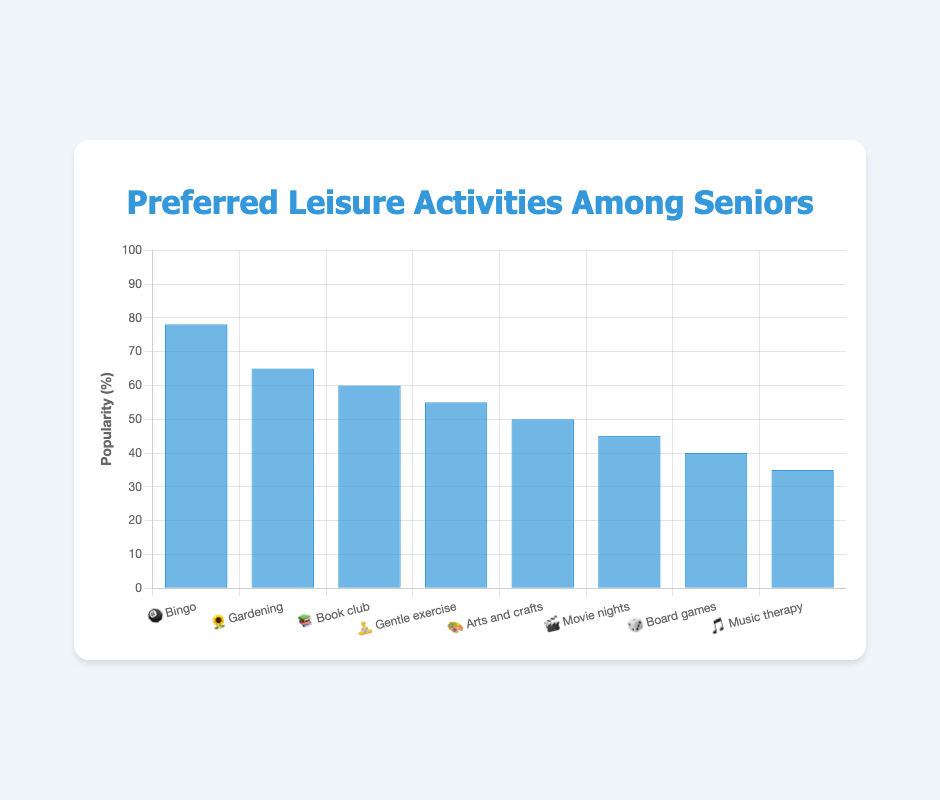What is the most popular leisure activity among seniors? Look at the top bar of the chart to identify the activity with the highest popularity percentage. The bar for "Bingo" 🎱 reaches 78%, which is the highest.
Answer: Bingo 🎱 Which activity has a popularity of 55%? Check each bar label and its corresponding height until finding the one that corresponds to 55%. "Gentle exercise" 🧘 has a 55% popularity.
Answer: Gentle exercise 🧘 How much more popular is Bingo 🎱 compared to Arts and crafts 🎨? Identify and subtract the popularity percentages for Bingo (78%) and Arts and crafts (50%). The difference is 78% - 50% = 28%.
Answer: 28% What is the total popularity percentage of Gardening 🌻 and Book club 📚? Identify the popularity percentages for Gardening (65%) and Book club (60%) and add them together. The total is 65% + 60% = 125%.
Answer: 125% Which two activities have the closest popularity percentages? Compare the popularity percentages of all activities and find the pair with the smallest difference. "Arts and crafts" 🎨 (50%) and "Movie nights" 🎬 (45%) have a 5% difference.
Answer: Arts and crafts 🎨 and Movie nights 🎬 How many activities have a popularity above 50%? Count the number of activities whose bars exceed the 50% mark. The activities are Bingo, Gardening, Book club, and Gentle exercise, totaling 4.
Answer: 4 What is the least popular activity among seniors? Look at the shortest bar in the chart, which corresponds to the lowest percentage. "Music therapy" 🎵 has the lowest popularity at 35%.
Answer: Music therapy 🎵 Which activity is more popular, Board games 🎲 or Music therapy 🎵? Compare the heights of the bars labeled "Board games" and "Music therapy". "Board games" is at 40%, while "Music therapy" is at 35%, so Board games is more popular.
Answer: Board games 🎲 What is the average popularity of all the stated leisure activities? Sum all popularity percentages (78% + 65% + 60% + 55% + 50% + 45% + 40% + 35%) and divide by the number of activities (8). The average is (428 / 8) = 53.5%.
Answer: 53.5% What is the combined popularity percentage of activities involving physical exercise? Identify and sum the popularity percentages for "Gardening" (65%) and "Gentle exercise" (55%), which both involve physical activity. The combined popularity is 65% + 55% = 120%.
Answer: 120% 